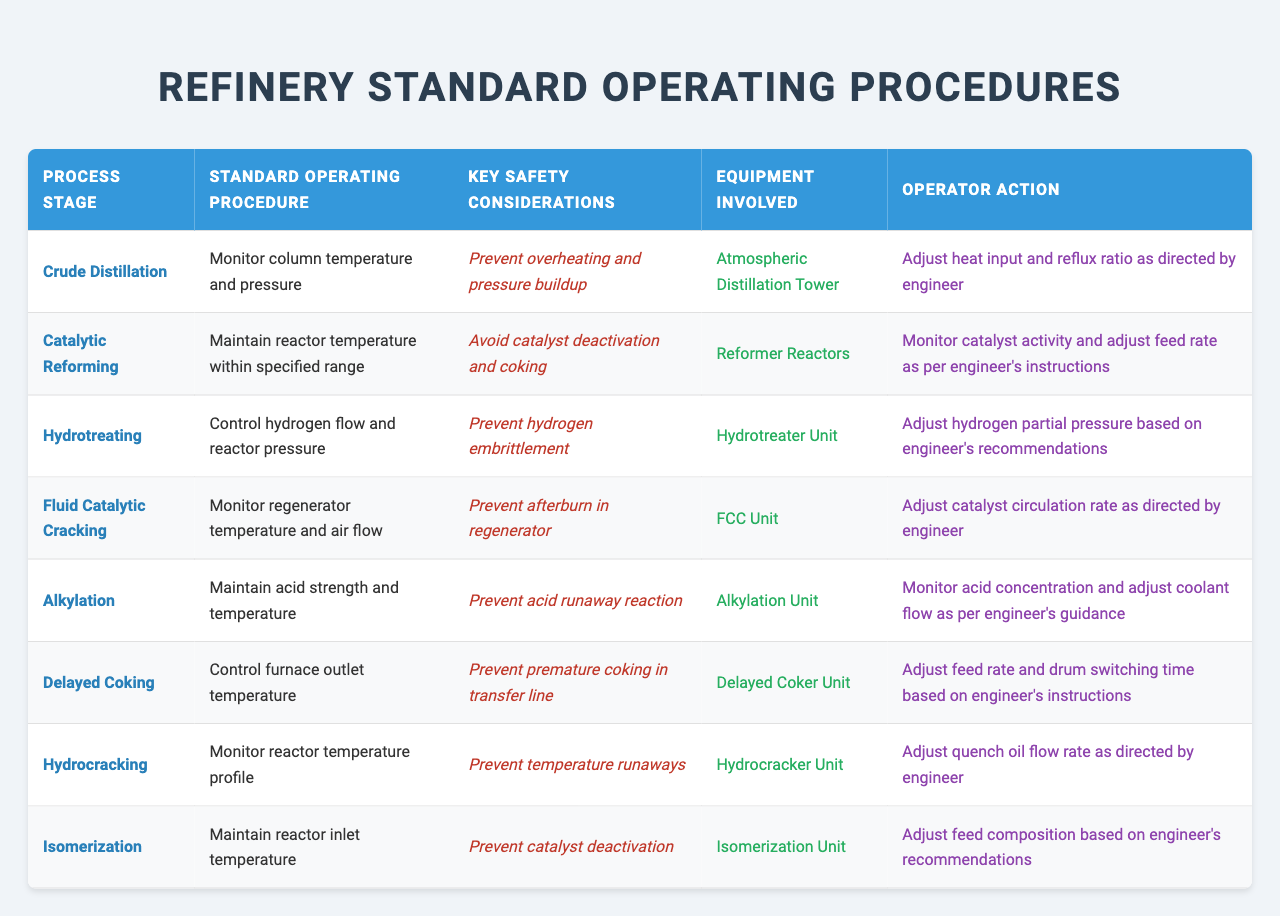What is the standard operating procedure for Crude Distillation? The table indicates that the standard operating procedure for Crude Distillation is to monitor column temperature and pressure.
Answer: Monitor column temperature and pressure Which process stage requires monitoring the reactor temperature profile? According to the table, the Hydrocracking stage requires monitoring the reactor temperature profile as part of its procedures.
Answer: Hydrocracking True or False: Preventing hydrogen embrittlement is a safety consideration in the Hydrotreating process. The table lists preventing hydrogen embrittlement as a safety consideration specifically for the Hydrotreating process, confirming it is true.
Answer: True What are the key safety considerations for the Alkylation stage? The table specifies that the key safety considerations for the Alkylation stage include preventing acid runaway reaction.
Answer: Prevent acid runaway reaction Compare the operator action for Fluid Catalytic Cracking and Delayed Coking. For Fluid Catalytic Cracking, the operator is to adjust catalyst circulation rate, while for Delayed Coking, the operator adjusts feed rate and drum switching time.
Answer: Different operator actions Which unit's standard operating procedure involves maintaining reactor inlet temperature? The table indicates that the Isomerization Unit’s standard operating procedure involves maintaining reactor inlet temperature.
Answer: Isomerization Unit What temperature should be monitored in the Catalytic Reforming stage? The standard procedure for Catalytic Reforming involves maintaining the reactor temperature within a specified range, answering this question.
Answer: Reactor temperature Identify a process stage where the operator adjusts hydrogen partial pressure based on engineer's recommendations. The table shows that in the Hydrotreating stage, the operator must adjust hydrogen partial pressure following the engineer’s recommendations.
Answer: Hydrotreating How do the safety considerations for Fluid Catalytic Cracking and Delayed Coking differ? Fluid Catalytic Cracking focuses on preventing afterburn in the regenerator, while Delayed Coking concentrates on preventing premature coking in the transfer line, indicating differing safety measures.
Answer: They focus on different hazards What equipment is involved in the Hydrotreating process? The table specifies that the equipment involved in the Hydrotreating process is the Hydrotreater Unit.
Answer: Hydrotreater Unit 